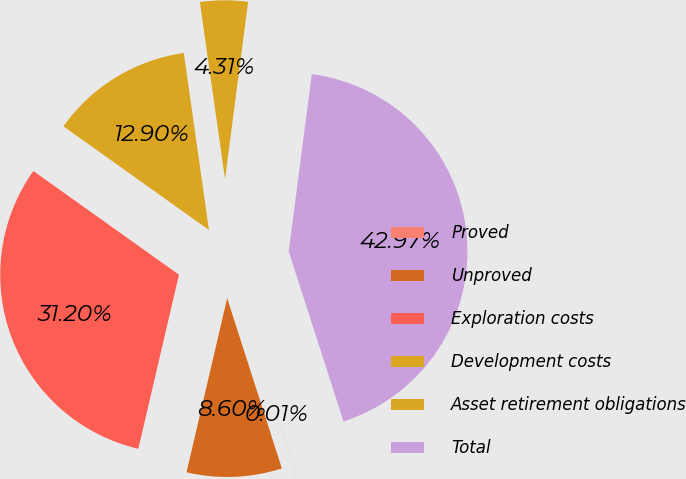<chart> <loc_0><loc_0><loc_500><loc_500><pie_chart><fcel>Proved<fcel>Unproved<fcel>Exploration costs<fcel>Development costs<fcel>Asset retirement obligations<fcel>Total<nl><fcel>0.01%<fcel>8.6%<fcel>31.2%<fcel>12.9%<fcel>4.31%<fcel>42.97%<nl></chart> 